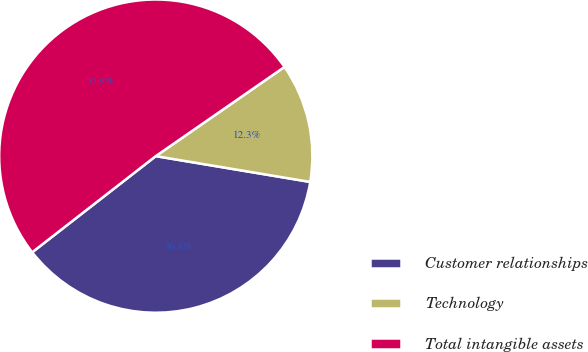<chart> <loc_0><loc_0><loc_500><loc_500><pie_chart><fcel>Customer relationships<fcel>Technology<fcel>Total intangible assets<nl><fcel>36.84%<fcel>12.28%<fcel>50.88%<nl></chart> 